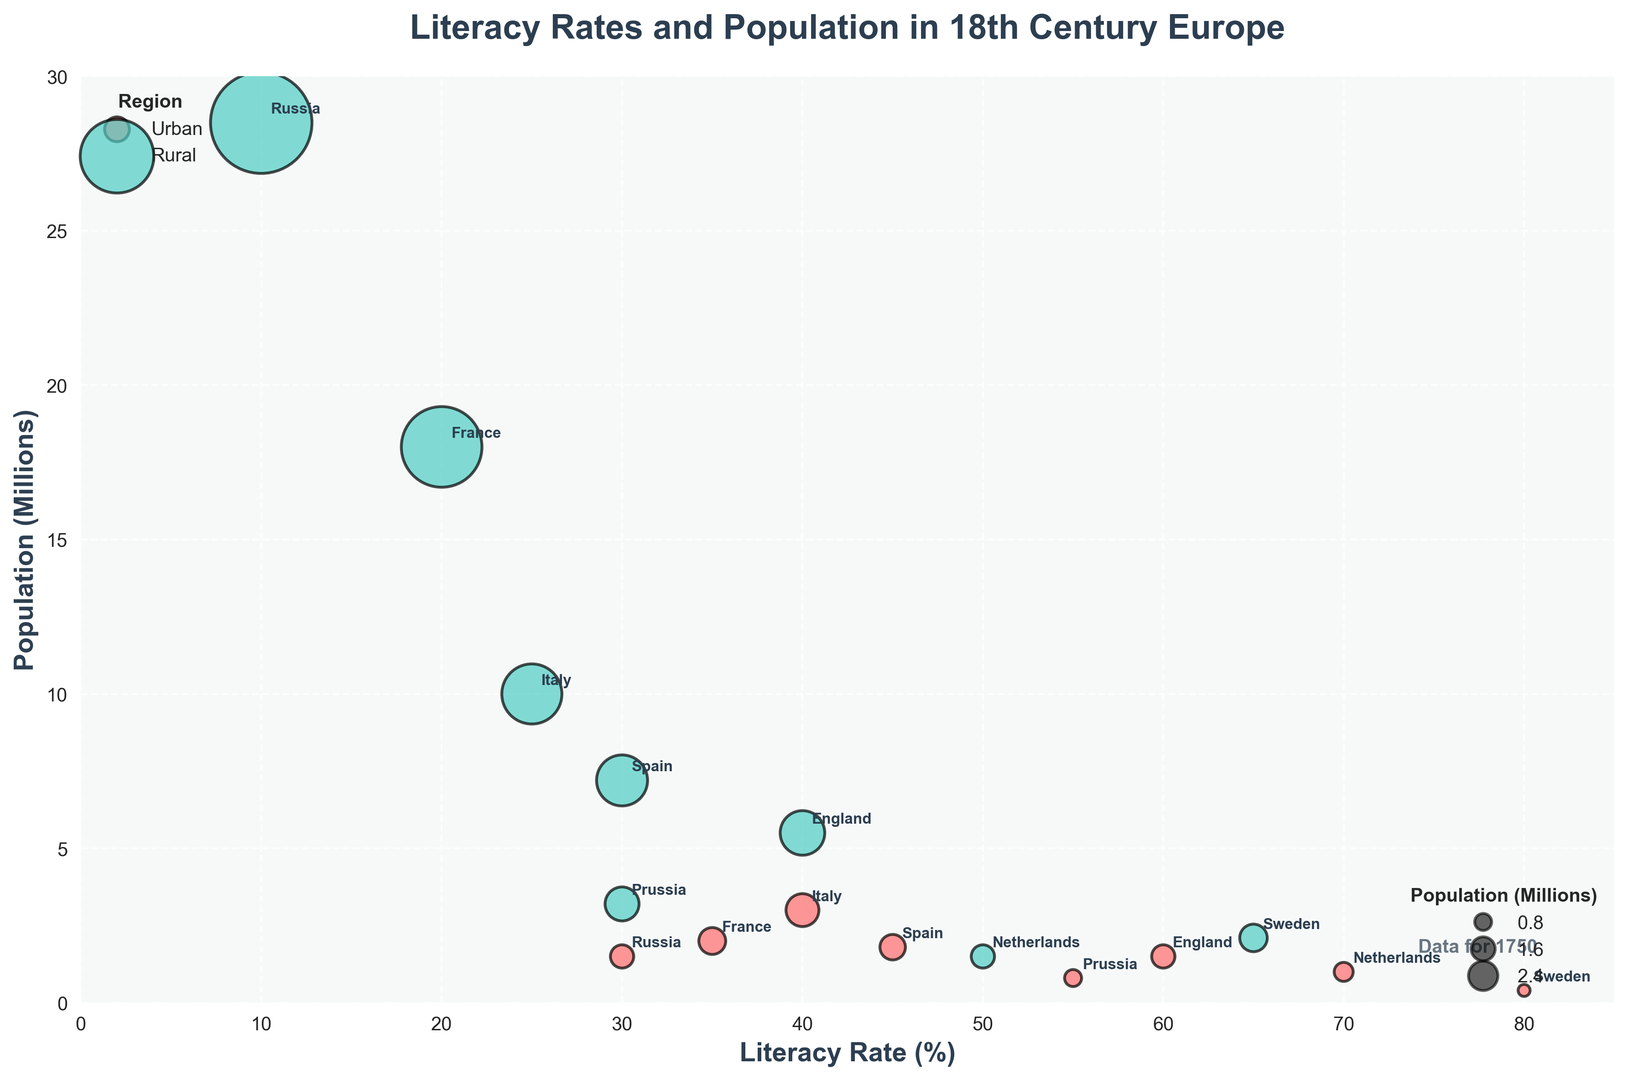Which country has the highest urban literacy rate? Sweden has the highest urban literacy rate at 80%, as indicated by the tallest red bubble in the 'Urban' category.
Answer: Sweden Which region, urban or rural, had a higher literacy rate in the Netherlands in 1750? Comparing the Dutch sections, the urban literacy rate (70%) is higher than the rural literacy rate (50%). The bubbles showing these rates can be found along the x-axis at 70% and 50% for urban and rural, respectively.
Answer: Urban Which country had the largest rural population in 1750? Russia has the largest rural population, represented by the biggest turquoise bubble on the y-axis with 28.5 million.
Answer: Russia What is the total population for urban and rural Sweden? Adding the urban population (400,000) and rural population (2,100,000) for Sweden, the total is 2,500,000, or 2.5 million.
Answer: 2.5 million How do the literacy rates in rural areas compare between France and Italy? The literacy rate is 20% in rural France and 25% in rural Italy, shown by the positioning of the turquoise bubbles on the x-axis. Italy's rural literacy rate is higher.
Answer: Italy In which country is the difference between urban and rural literacy rates largest? In Russia, the difference between urban (30%) and rural (10%) literacy rates is 20%, the largest disparity among the countries, as shown by the furthest red and turquoise bubbles apart in this category.
Answer: Russia What is the population difference between urban and rural England? The urban population of England is 1.5 million, and the rural population is 5.5 million. The difference is 5.5 million - 1.5 million = 4 million.
Answer: 4 million Which country has the smallest gap between urban and rural literacy rates? Sweden has a gap of 15% between its urban rate (80%) and rural rate (65%), the smallest gap visible along the x-axis.
Answer: Sweden Which region has a lower overall average literacy rate, urban or rural? Averaging the urban and rural literacy rates across all recorded countries: Urban: (35 + 60 + 55 + 70 + 40 + 45 + 80 + 30) / 8 = 52.125% Rural: (20 + 40 + 30 + 50 + 25 + 30 + 65 + 10) / 8 = 33.75% Thus, rural areas have a lower overall average literacy rate.
Answer: Rural 